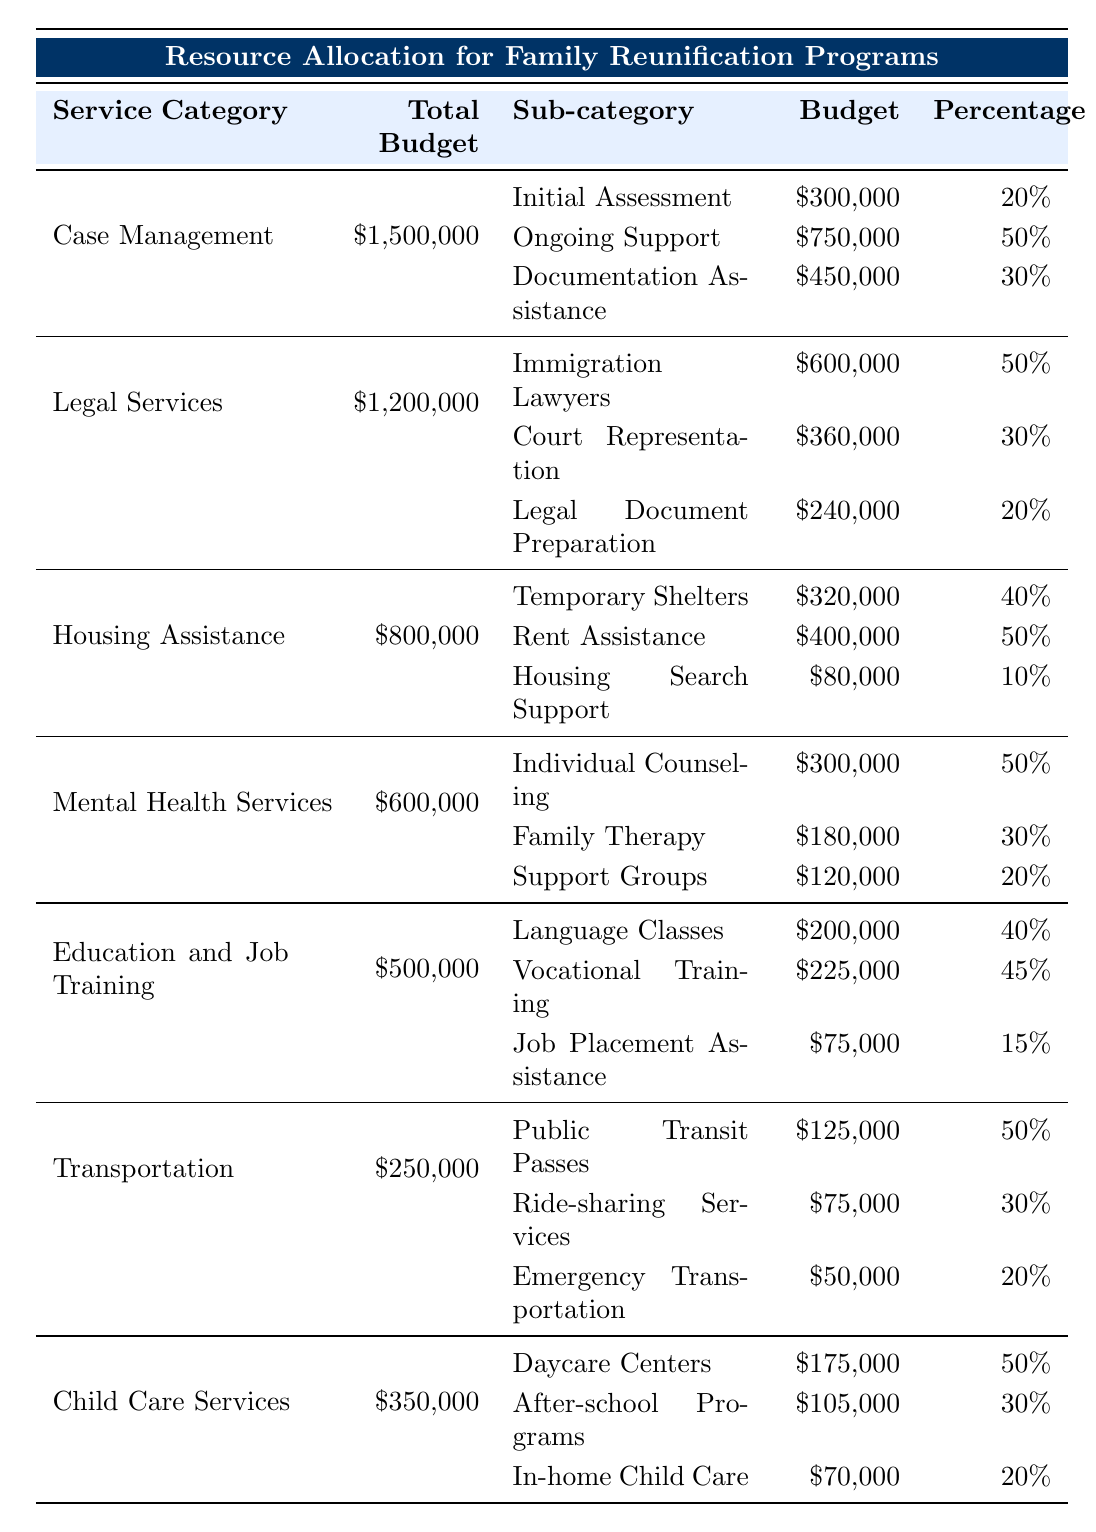What is the total budget allocated for Case Management services? The table shows that the total budget for Case Management is $1,500,000, directly stated under the Total Budget column for that service category.
Answer: $1,500,000 How much is allocated for Ongoing Support under Case Management? The sub-category "Ongoing Support" under Case Management has a budget listed as $750,000, which can be found in the corresponding row of the table.
Answer: $750,000 Which service category has the highest total budget? Comparing the total budgets of all service categories, Case Management has $1,500,000, which is higher than the next highest category, Legal Services at $1,200,000.
Answer: Case Management What percentage of the budget for Mental Health Services goes to Individual Counseling? The table indicates that the budget for Individual Counseling is $300,000, which is 50% of the total budget of $600,000 for Mental Health Services.
Answer: 50% What is the combined budget for all sub-categories under Housing Assistance? To find the combined budget, add the budgets of Temporary Shelters ($320,000), Rent Assistance ($400,000), and Housing Search Support ($80,000) which results in $800,000 ($320,000 + $400,000 + $80,000).
Answer: $800,000 Is the budget for Family Therapy greater than the budget for After-school Programs? The budget for Family Therapy is $180,000 and the budget for After-school Programs is $105,000. $180,000 is greater than $105,000, making the statement true.
Answer: Yes What is the average budget allocation for the sub-categories in Legal Services? The total budget for Legal Services is $1,200,000, and there are three sub-categories: Immigration Lawyers ($600,000), Court Representation ($360,000), and Legal Document Preparation ($240,000). Adding these gives $1,200,000, and dividing by 3 gives an average of $400,000 ($1,200,000 / 3).
Answer: $400,000 If the budget for Documentation Assistance were reduced by 10%, what would the new budget be? The original budget for Documentation Assistance is $450,000. A 10% reduction would equal $45,000. Subtracting this from the original budget gives $405,000 ($450,000 - $45,000).
Answer: $405,000 How much budget does Housing Assistance allocate to Rent Assistance and how does it compare to the budget for Daycare Centers in Child Care Services? Housing Assistance allocates $400,000 for Rent Assistance, while Daycare Centers in Child Care Services has a budget of $175,000. Comparing these, $400,000 is significantly higher than $175,000.
Answer: $400,000 is higher What is the total budget for Transportation services? According to the table, the total budget allocated for Transportation is $250,000, which is explicitly stated in the Total Budget column for that service category.
Answer: $250,000 